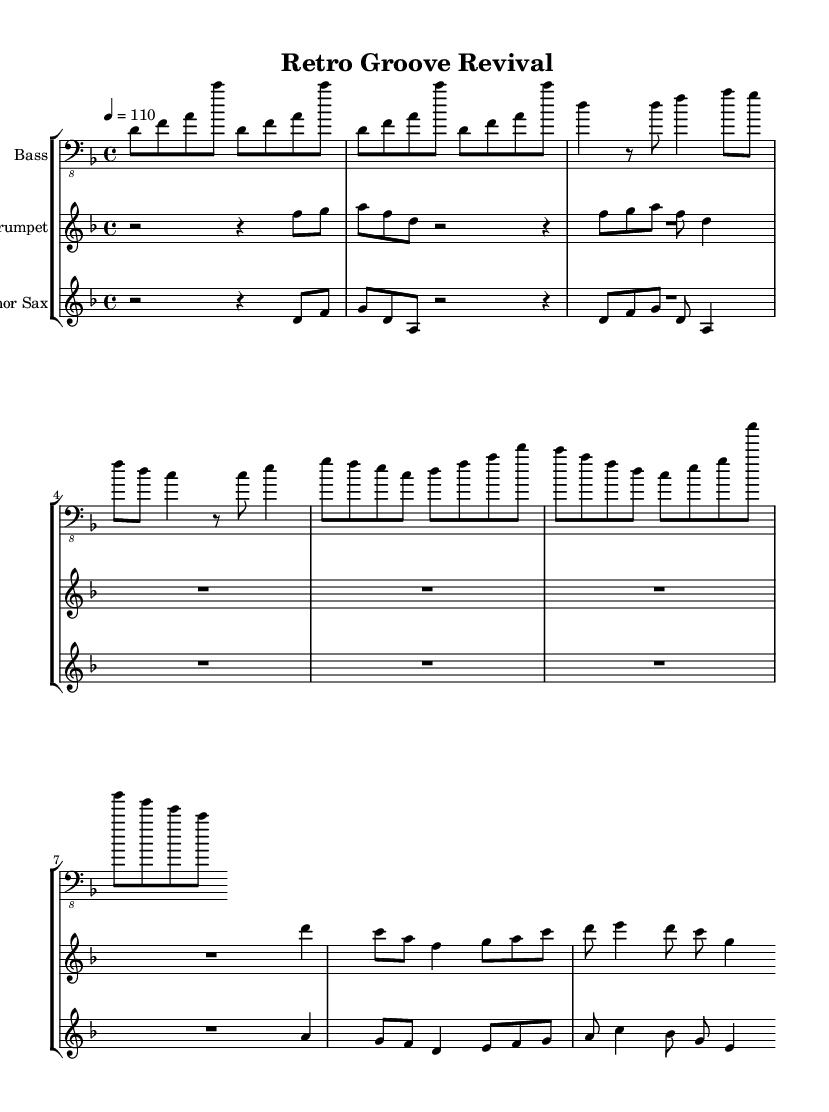What is the key signature of this music? The key signature is D minor, which is indicated by one flat (B flat) in the key signature section of the staff.
Answer: D minor What is the time signature of this music? The time signature is 4/4, which is shown at the beginning of the score following the key signature. This means there are four beats in each measure with a quarter note getting one beat.
Answer: 4/4 What is the tempo marking for this piece? The tempo marking is 110 BPM (beats per minute), which is indicated at the start of the score next to the tempo instruction "4 = 110".
Answer: 110 How many bars are in the intro section? The intro section consists of 4 bars, as seen in the notation for the bass and trumpet parts where the introduction repeats a defined figure.
Answer: 4 Which instruments are featured in this composition? The composition features three instruments: Bass, Trumpet, and Tenor Sax, as indicated at the beginning of each staff.
Answer: Bass, Trumpet, Tenor Sax What rhythmic pattern is predominantly used in the bassline? The bassline predominantly utilizes a mix of eighth and quarter notes, creating a funk groove typical of the genre, specifically evident in the repeated pattern throughout the intro and chorus.
Answer: Eighth and quarter notes What is the overall texture of the music based on the arrangement? The overall texture is polyphonic, as it features multiple independent melodic lines from the bass, trumpet, and tenor sax, which interact rhythmically and melodically throughout the piece.
Answer: Polyphonic 